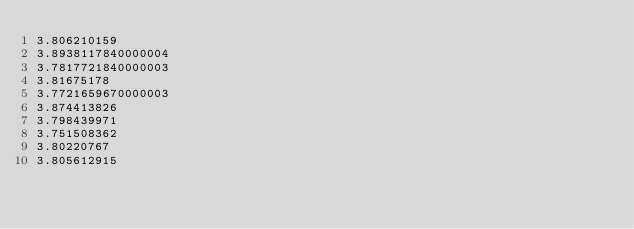<code> <loc_0><loc_0><loc_500><loc_500><_SQL_>3.806210159
3.8938117840000004
3.7817721840000003
3.81675178
3.7721659670000003
3.874413826
3.798439971
3.751508362
3.80220767
3.805612915
</code> 